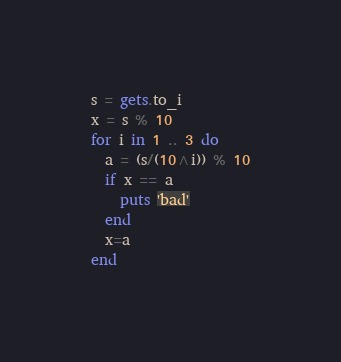<code> <loc_0><loc_0><loc_500><loc_500><_Ruby_>s = gets.to_i
x = s % 10
for i in 1 .. 3 do
  a = (s/(10^i)) % 10
  if x == a
    puts 'bad'
  end
  x=a
end
</code> 